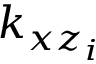Convert formula to latex. <formula><loc_0><loc_0><loc_500><loc_500>k _ { x z _ { i } }</formula> 